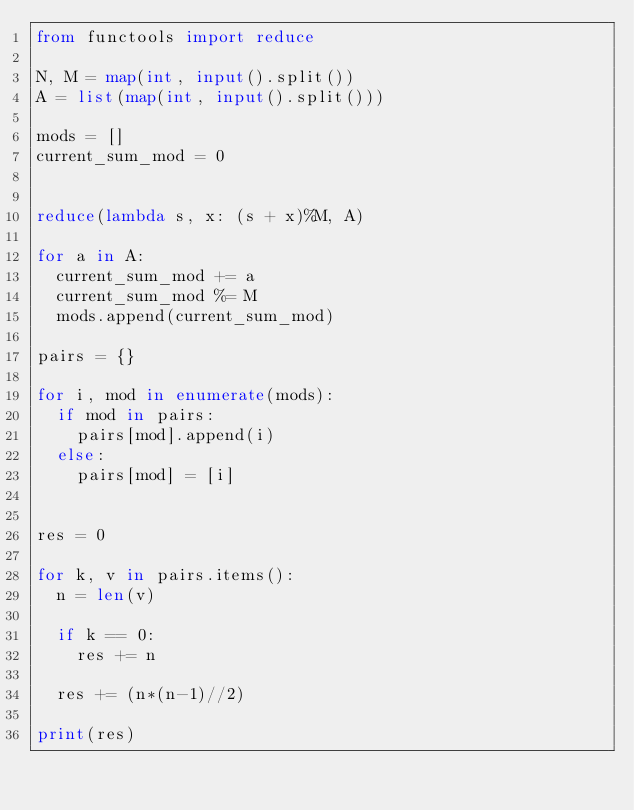Convert code to text. <code><loc_0><loc_0><loc_500><loc_500><_Python_>from functools import reduce

N, M = map(int, input().split())
A = list(map(int, input().split()))

mods = []
current_sum_mod = 0


reduce(lambda s, x: (s + x)%M, A)

for a in A:
  current_sum_mod += a
  current_sum_mod %= M
  mods.append(current_sum_mod)

pairs = {}

for i, mod in enumerate(mods):
  if mod in pairs:
    pairs[mod].append(i)
  else:
    pairs[mod] = [i]


res = 0

for k, v in pairs.items():
  n = len(v)

  if k == 0:
    res += n

  res += (n*(n-1)//2)

print(res)
</code> 